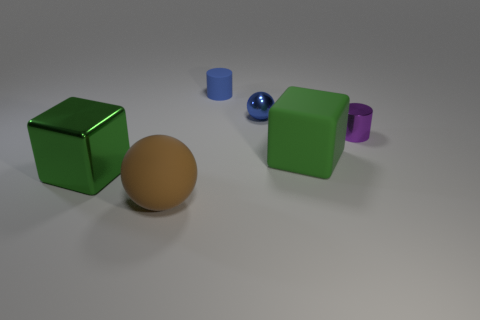What color is the big object on the right side of the blue matte object?
Your answer should be very brief. Green. The metallic object that is the same size as the matte sphere is what shape?
Provide a succinct answer. Cube. There is a large green matte cube; how many big matte spheres are behind it?
Make the answer very short. 0. How many things are tiny blue cylinders or small cylinders?
Your response must be concise. 2. The large thing that is both behind the brown rubber thing and on the left side of the blue cylinder has what shape?
Make the answer very short. Cube. How many matte things are there?
Offer a terse response. 3. The sphere that is made of the same material as the blue cylinder is what color?
Your answer should be very brief. Brown. Are there more small brown rubber cylinders than cubes?
Offer a very short reply. No. How big is the object that is right of the green metal object and to the left of the tiny blue cylinder?
Offer a terse response. Large. There is a object that is the same color as the rubber cylinder; what material is it?
Provide a succinct answer. Metal. 